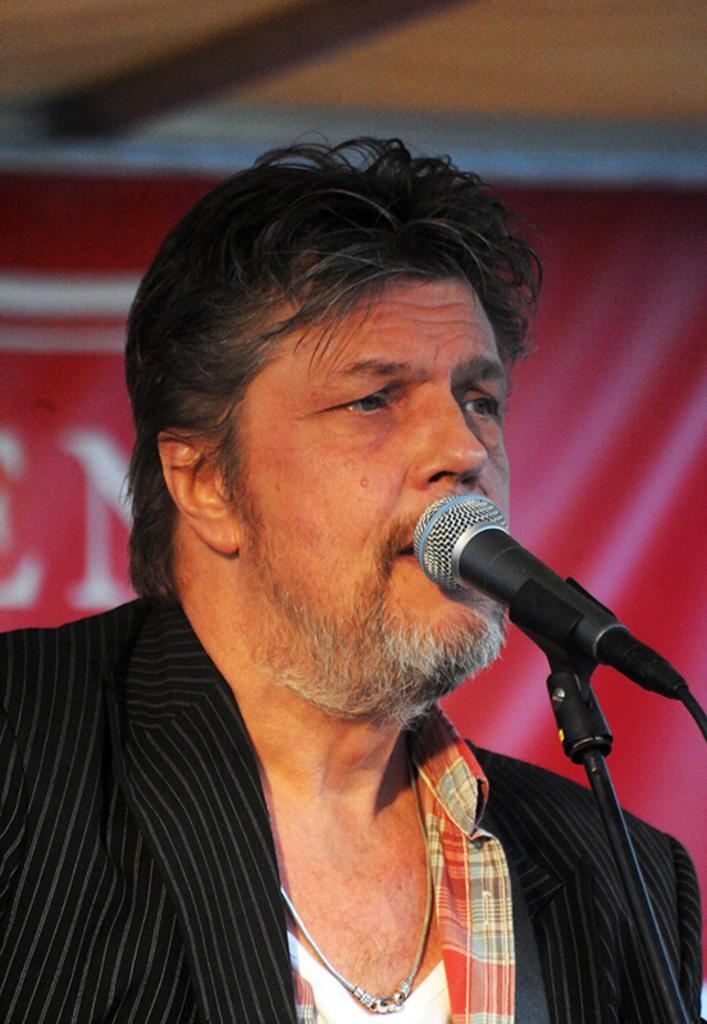Who or what is present in the image? There is a person in the image. What object is visible near the person? There is a microphone in the image. What can be seen in the background of the image? There is a poster with text in the background of the image. What part of a building can be seen in the image? The roof is visible in the image. What type of bushes can be seen in the lunchroom in the image? There are no bushes or lunchroom present in the image. 